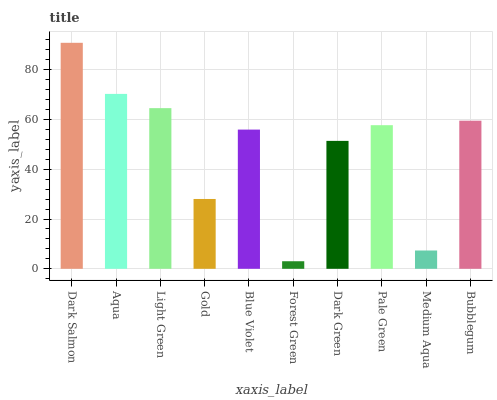Is Forest Green the minimum?
Answer yes or no. Yes. Is Dark Salmon the maximum?
Answer yes or no. Yes. Is Aqua the minimum?
Answer yes or no. No. Is Aqua the maximum?
Answer yes or no. No. Is Dark Salmon greater than Aqua?
Answer yes or no. Yes. Is Aqua less than Dark Salmon?
Answer yes or no. Yes. Is Aqua greater than Dark Salmon?
Answer yes or no. No. Is Dark Salmon less than Aqua?
Answer yes or no. No. Is Pale Green the high median?
Answer yes or no. Yes. Is Blue Violet the low median?
Answer yes or no. Yes. Is Light Green the high median?
Answer yes or no. No. Is Pale Green the low median?
Answer yes or no. No. 